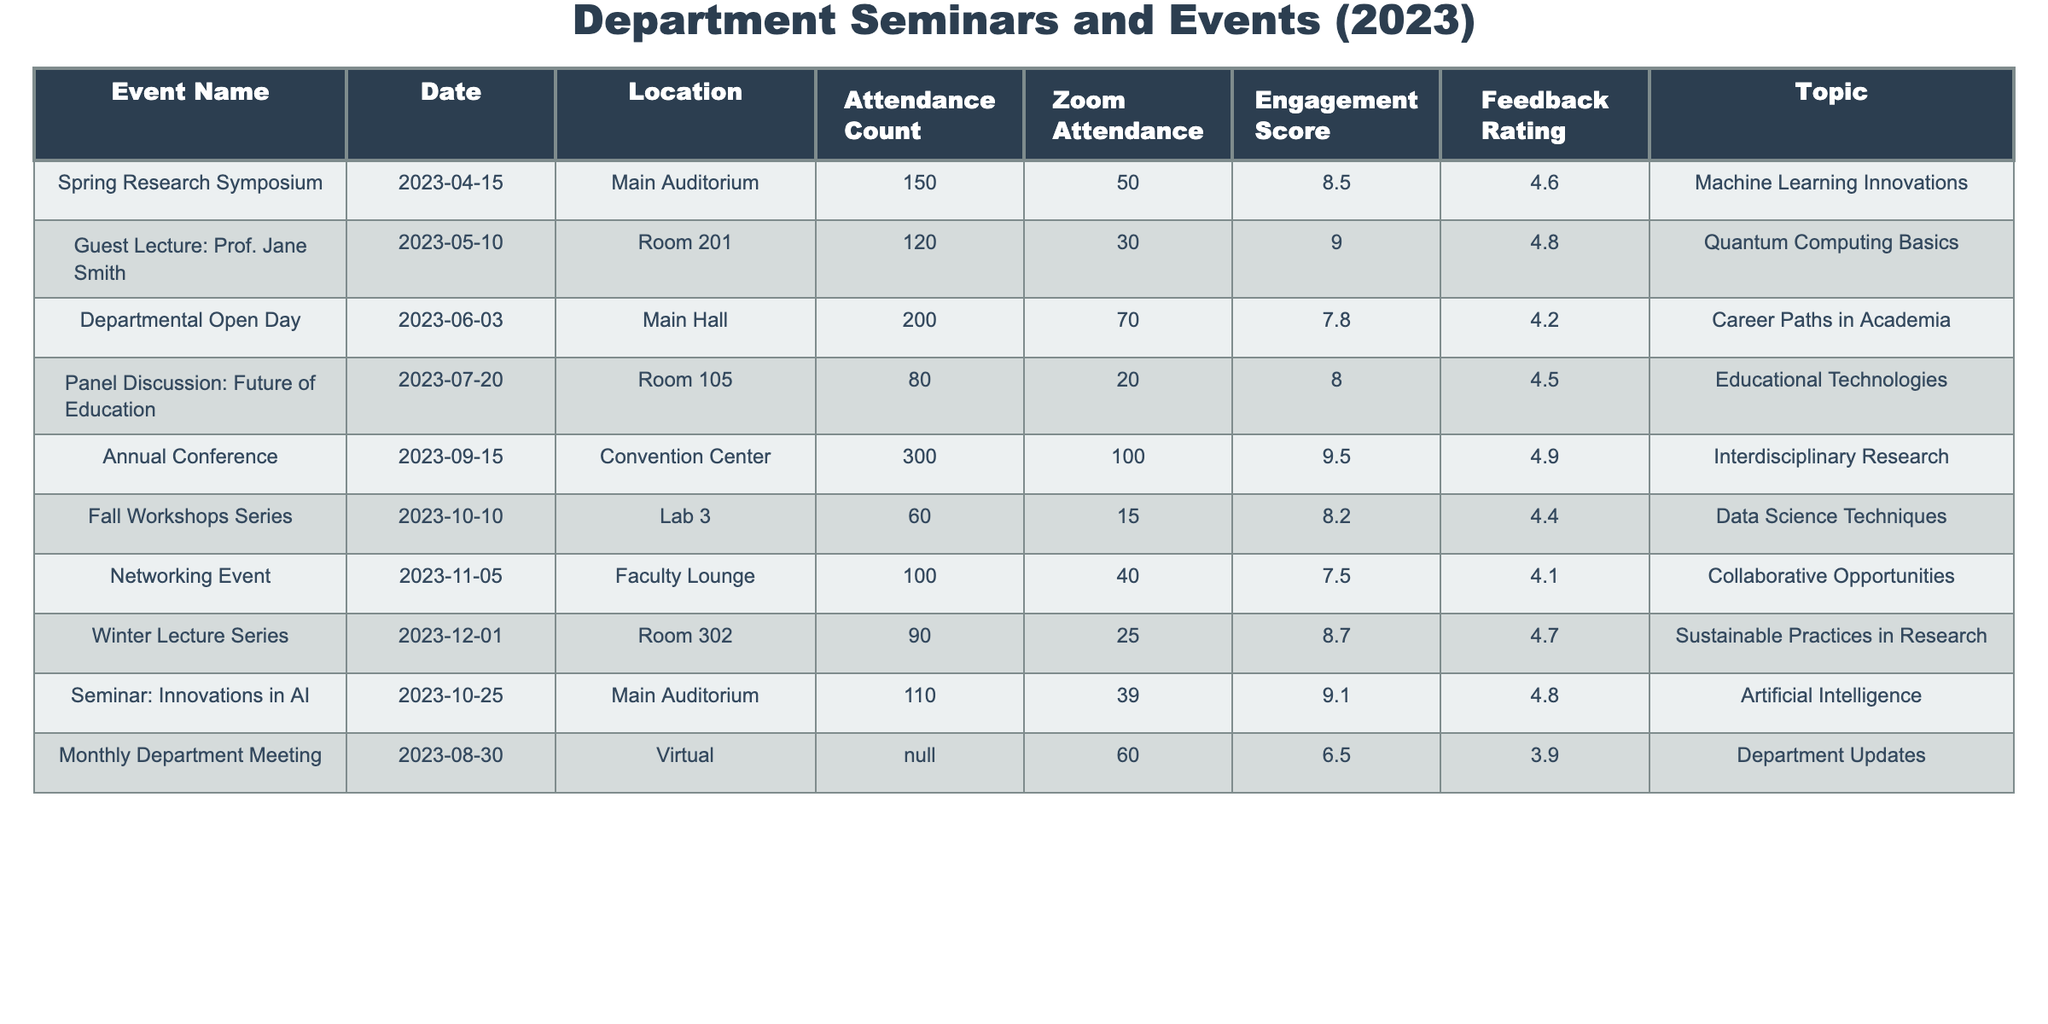What was the attendance count for the "Annual Conference"? The attendance count for the "Annual Conference" is listed in the table. By checking the row for that specific event, it shows that the attendance count is 300.
Answer: 300 What is the engagement score for the "Guest Lecture: Prof. Jane Smith"? The engagement score for the event can be found in the table under the Engagement Score column for that event. It indicates a score of 9.0.
Answer: 9.0 Which event had the highest Feedback Rating? To determine the highest Feedback Rating, I will review the Feedback Rating column and find the maximum value. The "Annual Conference" has a Feedback Rating of 4.9, which is the highest among all listed events.
Answer: "Annual Conference" What was the average attendance count across all events? First, I will sum the attendance counts from all events: 150 + 120 + 200 + 80 + 300 + 60 + 100 + 90 + 110 + 60 = 1,270. There are 10 events, so the average attendance count is 1,270 divided by 10, which equals 127.
Answer: 127 Is the engagement score for the "Departmental Open Day" greater than 8? I will check the engagement score for the "Departmental Open Day," which is recorded as 7.8. Since 7.8 is less than 8, the answer to the question is no.
Answer: No What was the difference between the Zoom attendance of the "Spring Research Symposium" and the "Panel Discussion: Future of Education"? The Zoom attendance for "Spring Research Symposium" is 50, and for "Panel Discussion: Future of Education," it is 20. The difference is calculated as 50 - 20 = 30.
Answer: 30 Which event had the lowest overall attendance including Zoom? First, I will check the attendance count and Zoom attendance for each event. For the "Fall Workshops Series," the attendance count is 60 and the Zoom attendance is 15, giving a total of 60 + 15 = 75. This is lower than all other events when calculated.
Answer: "Fall Workshops Series" What is the topic of the event that received the second highest engagement score? I will review the Engagement Score column and rank the events. The second highest score is 9.1 for the "Seminar: Innovations in AI," which has that engagement score. Therefore, the topic of this event is "Artificial Intelligence."
Answer: "Artificial Intelligence" How many events had a Feedback Rating of 4.5 or higher? I will count the events in the Feedback Rating column that are 4.5 or above: "Guest Lecture: Prof. Jane Smith" (4.8), "Annual Conference" (4.9), "Panel Discussion: Future of Education" (4.5), "Winter Lecture Series" (4.7), and "Seminar: Innovations in AI" (4.8) total to 5 events.
Answer: 5 Was there any event held in the "Main Auditorium"? By reviewing the Location column, I can confirm that two events took place in the "Main Auditorium" — "Spring Research Symposium" and "Seminar: Innovations in AI." Therefore, the answer to this question is yes.
Answer: Yes What is the total attendance for all events that took place in the "Room 302"? There is only one event listed in the "Room 302," which is the "Winter Lecture Series" with an attendance count of 90. Hence, the total attendance is simply 90.
Answer: 90 